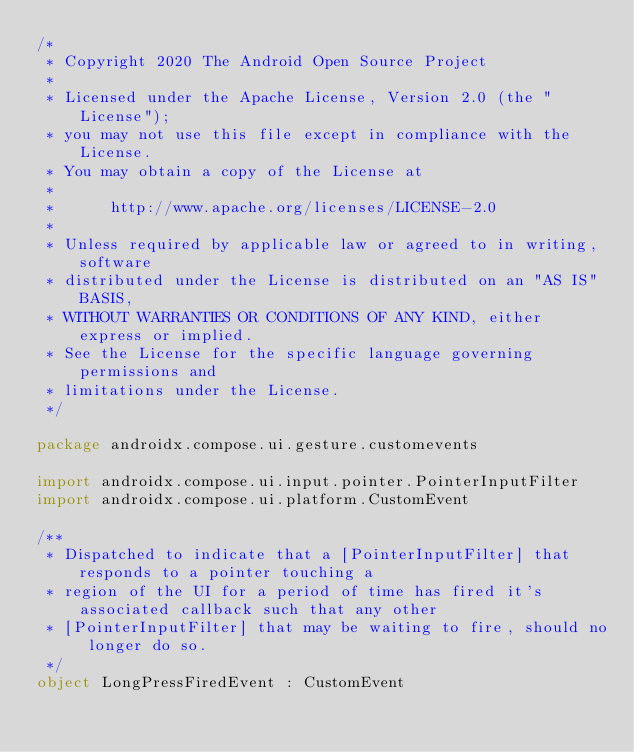Convert code to text. <code><loc_0><loc_0><loc_500><loc_500><_Kotlin_>/*
 * Copyright 2020 The Android Open Source Project
 *
 * Licensed under the Apache License, Version 2.0 (the "License");
 * you may not use this file except in compliance with the License.
 * You may obtain a copy of the License at
 *
 *      http://www.apache.org/licenses/LICENSE-2.0
 *
 * Unless required by applicable law or agreed to in writing, software
 * distributed under the License is distributed on an "AS IS" BASIS,
 * WITHOUT WARRANTIES OR CONDITIONS OF ANY KIND, either express or implied.
 * See the License for the specific language governing permissions and
 * limitations under the License.
 */

package androidx.compose.ui.gesture.customevents

import androidx.compose.ui.input.pointer.PointerInputFilter
import androidx.compose.ui.platform.CustomEvent

/**
 * Dispatched to indicate that a [PointerInputFilter] that responds to a pointer touching a
 * region of the UI for a period of time has fired it's associated callback such that any other
 * [PointerInputFilter] that may be waiting to fire, should no longer do so.
 */
object LongPressFiredEvent : CustomEvent</code> 